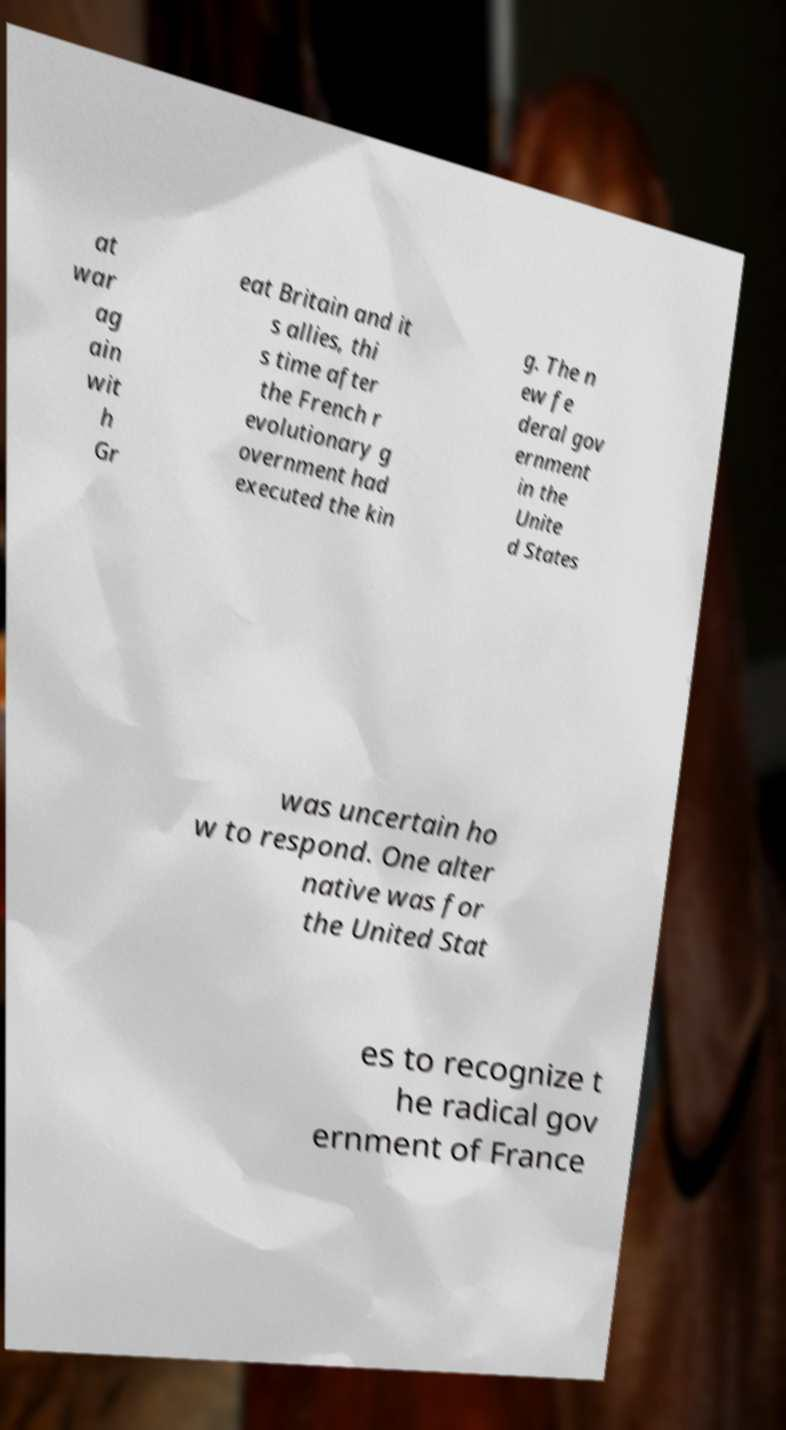Could you assist in decoding the text presented in this image and type it out clearly? at war ag ain wit h Gr eat Britain and it s allies, thi s time after the French r evolutionary g overnment had executed the kin g. The n ew fe deral gov ernment in the Unite d States was uncertain ho w to respond. One alter native was for the United Stat es to recognize t he radical gov ernment of France 